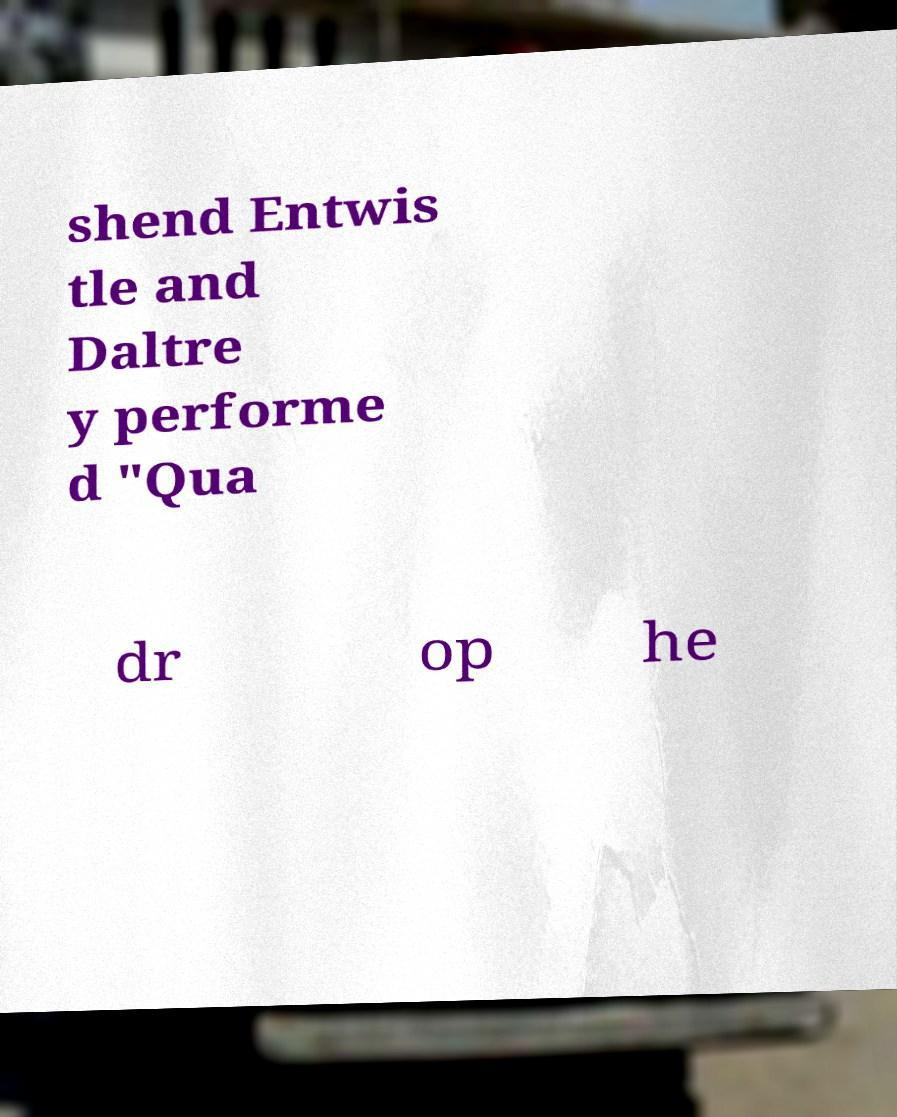Please read and relay the text visible in this image. What does it say? shend Entwis tle and Daltre y performe d "Qua dr op he 